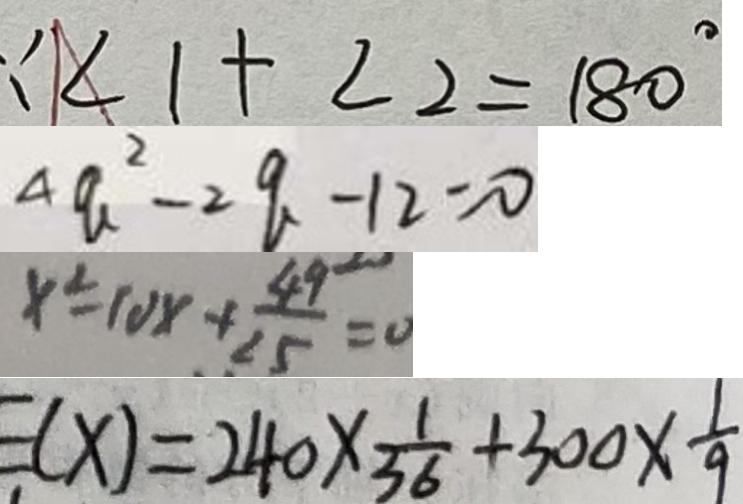<formula> <loc_0><loc_0><loc_500><loc_500>\because \angle 1 + \angle 2 = 1 8 0 ^ { \circ } 
 4 a ^ { 2 } - 2 q - 1 2 = 0 
 x ^ { 2 } = 1 0 x + \frac { 4 9 } { 2 5 } = 0 
 E ( x ) = 2 4 0 \times \frac { 1 } { 3 6 } + 3 0 0 \times \frac { 1 } { 9 }</formula> 